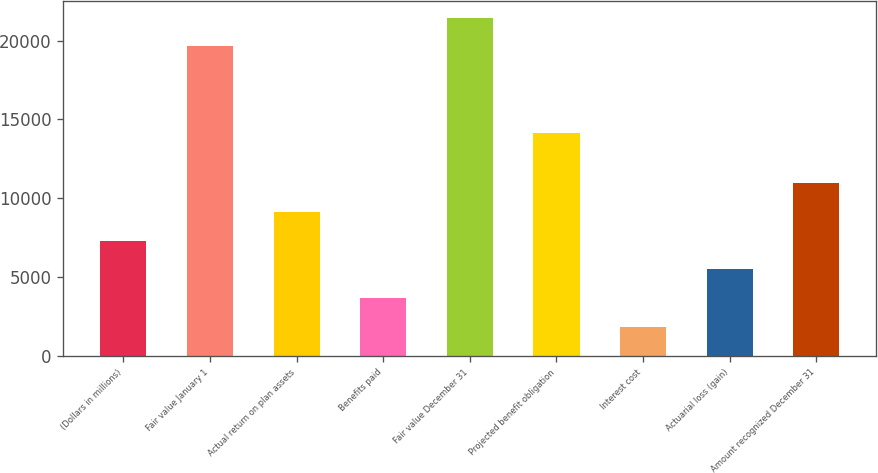<chart> <loc_0><loc_0><loc_500><loc_500><bar_chart><fcel>(Dollars in millions)<fcel>Fair value January 1<fcel>Actual return on plan assets<fcel>Benefits paid<fcel>Fair value December 31<fcel>Projected benefit obligation<fcel>Interest cost<fcel>Actuarial loss (gain)<fcel>Amount recognized December 31<nl><fcel>7313.32<fcel>19626.3<fcel>9140.43<fcel>3659.09<fcel>21453.5<fcel>14145<fcel>1831.97<fcel>5486.2<fcel>10967.5<nl></chart> 